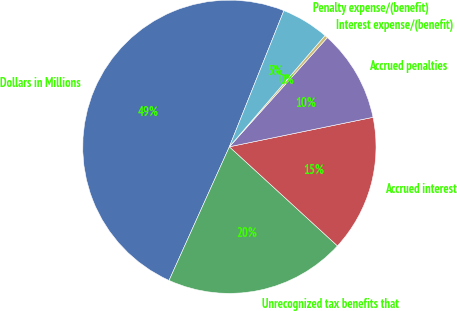Convert chart to OTSL. <chart><loc_0><loc_0><loc_500><loc_500><pie_chart><fcel>Dollars in Millions<fcel>Unrecognized tax benefits that<fcel>Accrued interest<fcel>Accrued penalties<fcel>Interest expense/(benefit)<fcel>Penalty expense/(benefit)<nl><fcel>49.31%<fcel>19.93%<fcel>15.03%<fcel>10.14%<fcel>0.34%<fcel>5.24%<nl></chart> 